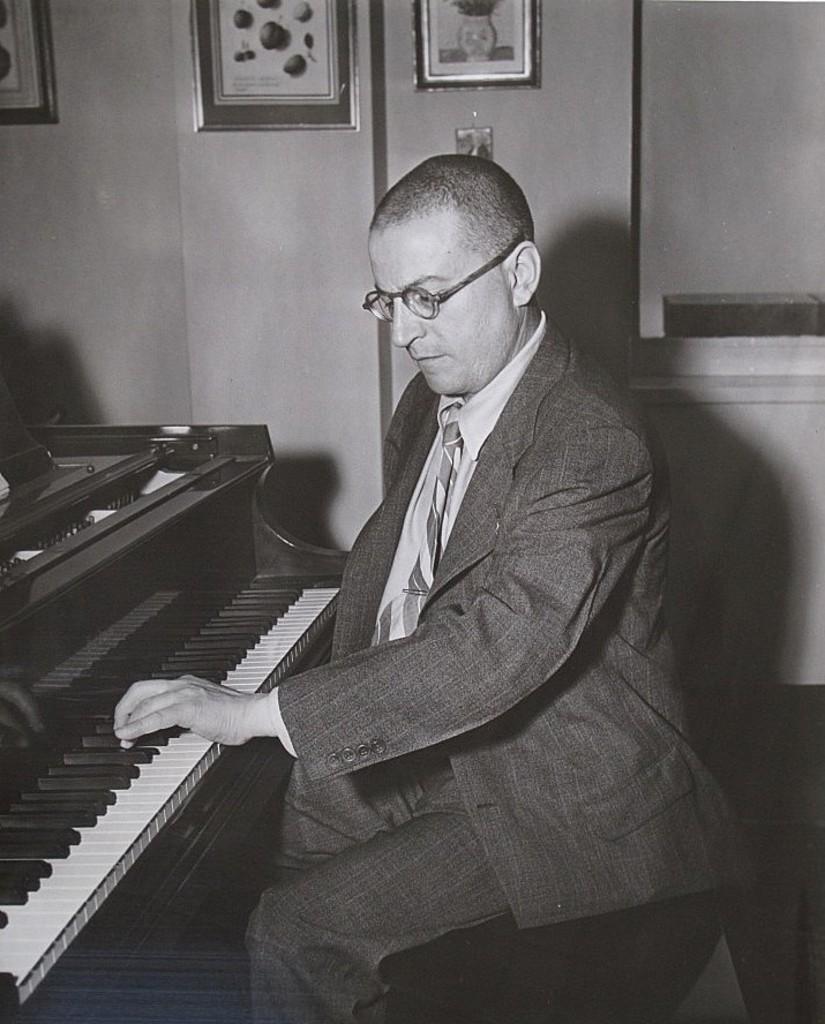How would you summarize this image in a sentence or two? In this image i can see a person sitting and a piano. In the background i can see a wall and few photo frames attached to it. 